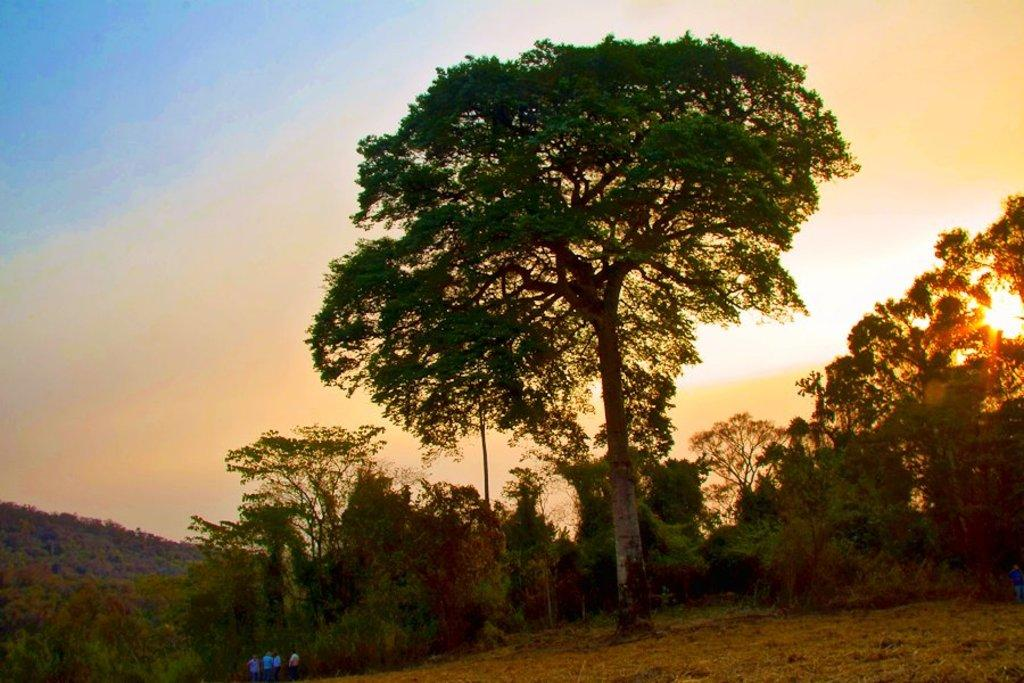What type of vegetation can be seen in the image? There are trees in the image. Where is the sun located in the image? The sun is visible on the right side of the image. What geographical feature is on the left side of the image? There is a hill on the left side of the image. What part of the natural environment is visible in the background of the image? The sky is visible in the background of the image. Who or what is present at the bottom of the image? There are people at the bottom of the image. What type of pie is being served on a quill in the image? There is no pie or quill present in the image; it features trees, a hill, the sun, the sky, and people. How many planes can be seen flying in the image? There are no planes visible in the image. 